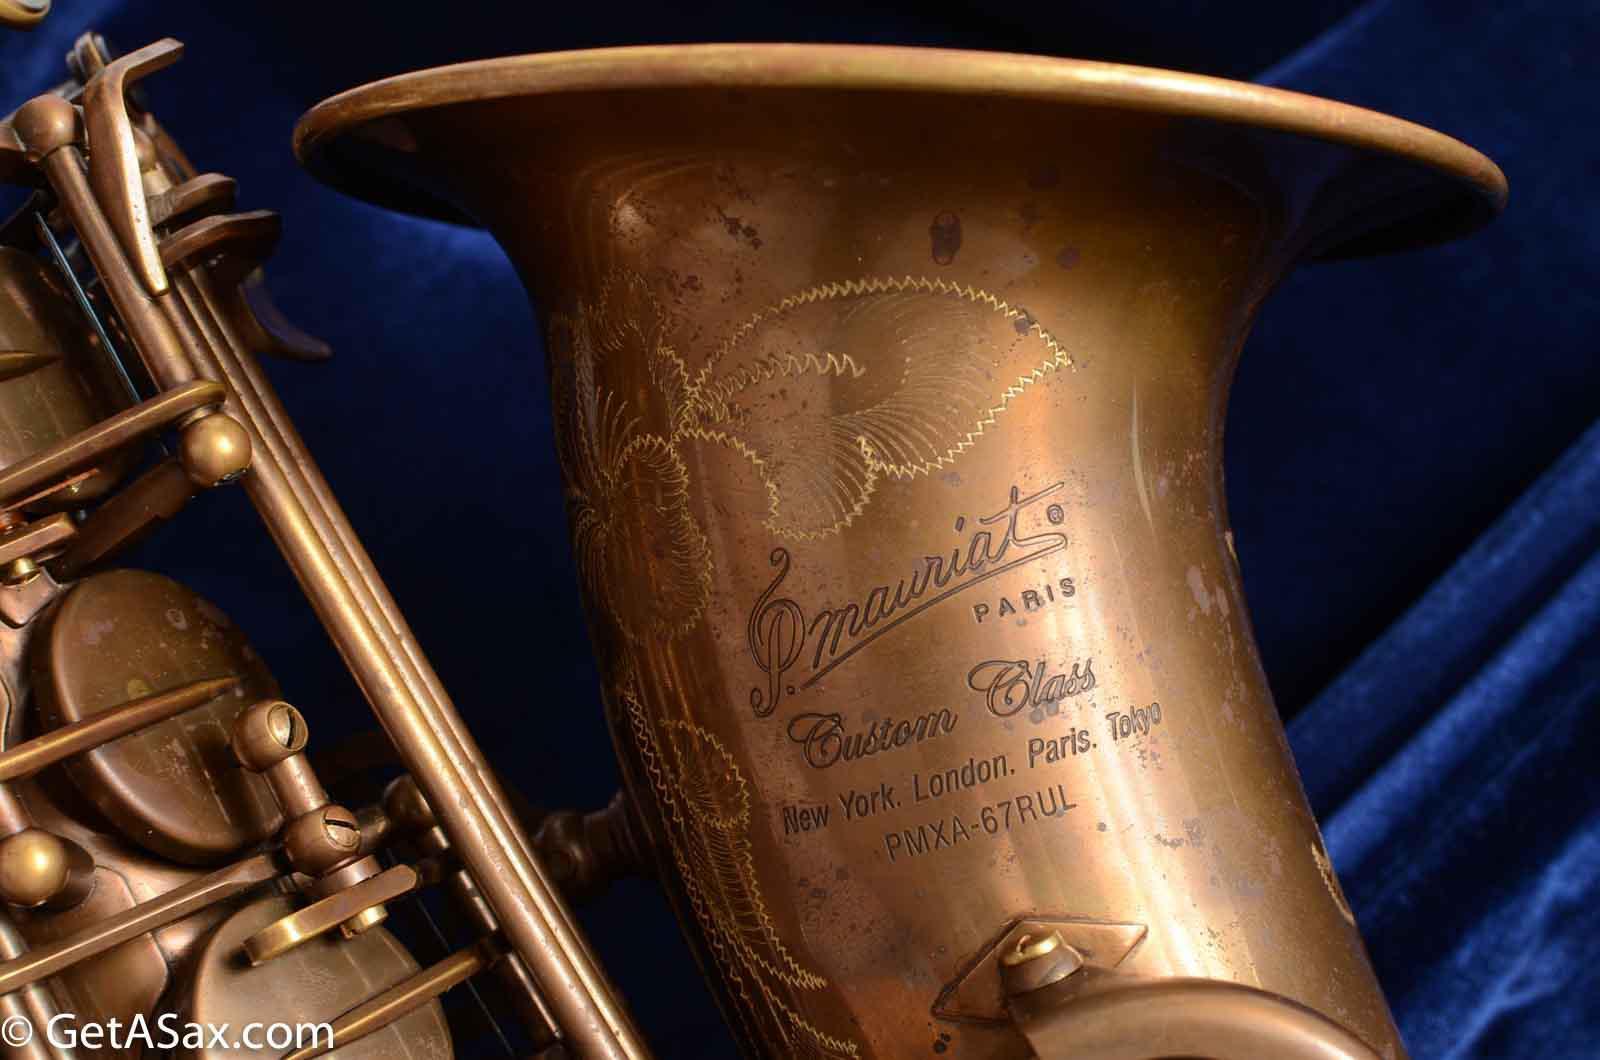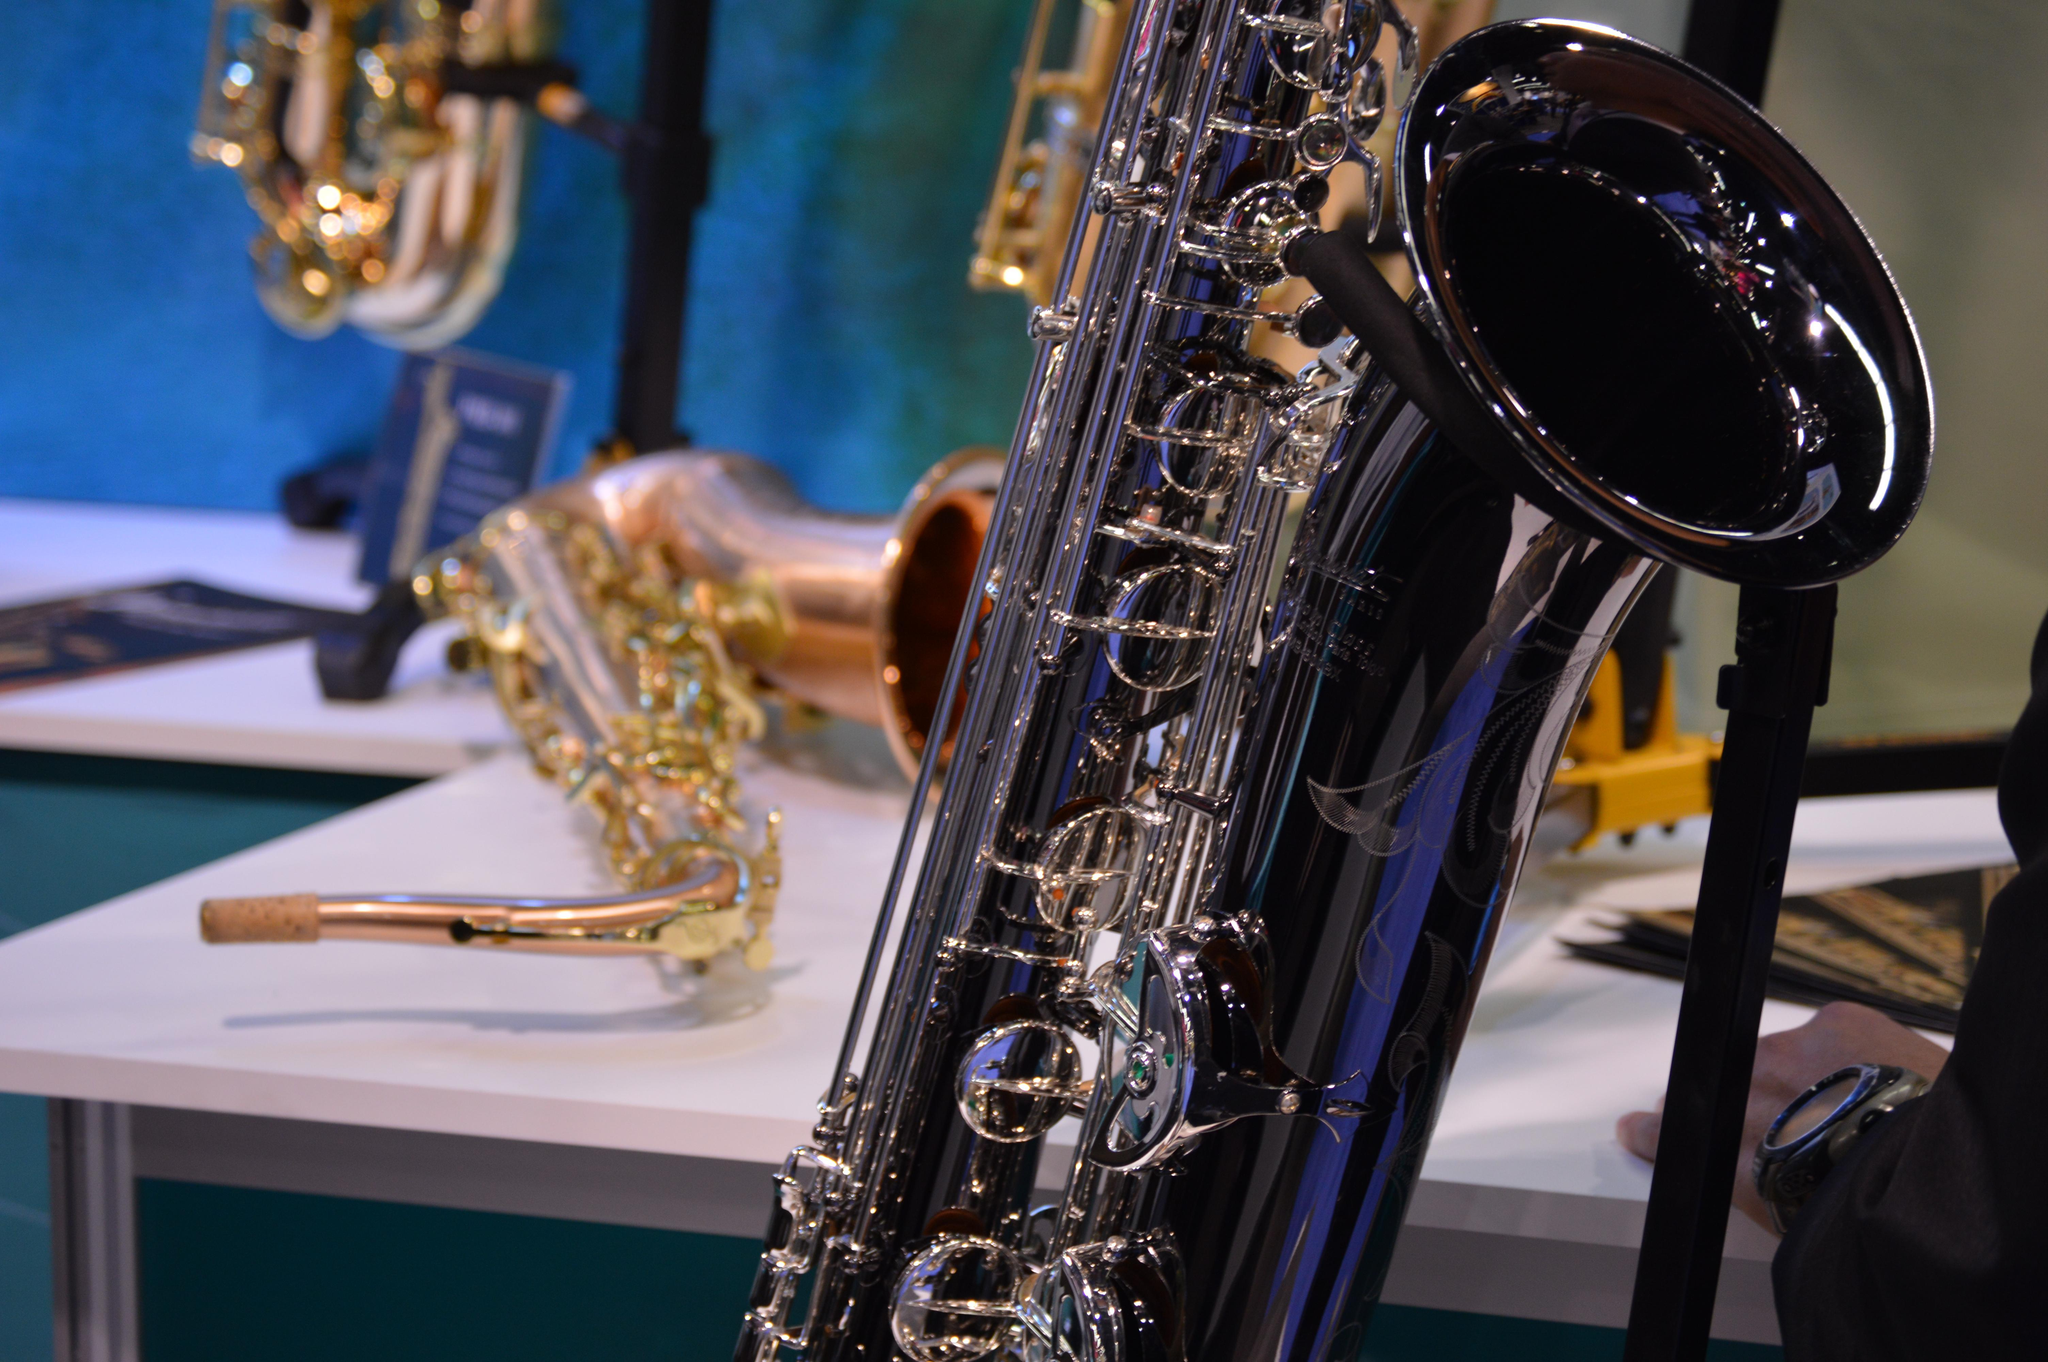The first image is the image on the left, the second image is the image on the right. Assess this claim about the two images: "The left image shows an upright saxophone with its bell facing right, and the right image features one saxophone that is gold-colored.". Correct or not? Answer yes or no. No. The first image is the image on the left, the second image is the image on the right. Evaluate the accuracy of this statement regarding the images: "The left and right image contains the same number of  fully sized saxophones.". Is it true? Answer yes or no. No. 